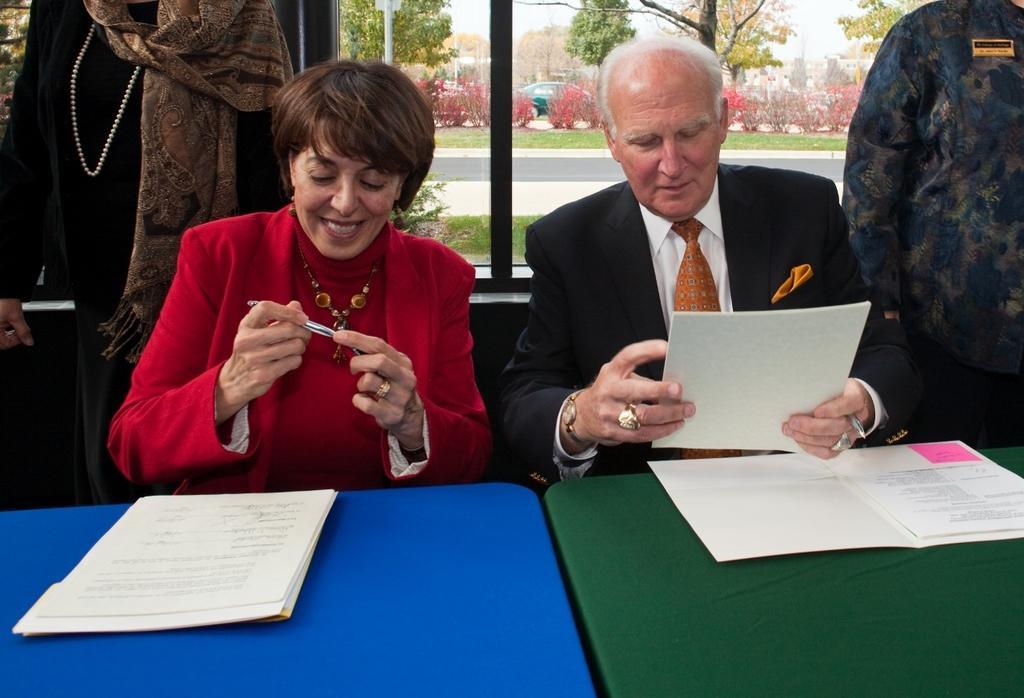How would you summarize this image in a sentence or two? This image consists of a woman wearing red dress. Beside her there is an old man wearing black suit. In front of them, there are tables on which papers are kept. In the background there is a window and two persons standing, through the window there are trees and plants along with road are seen. 